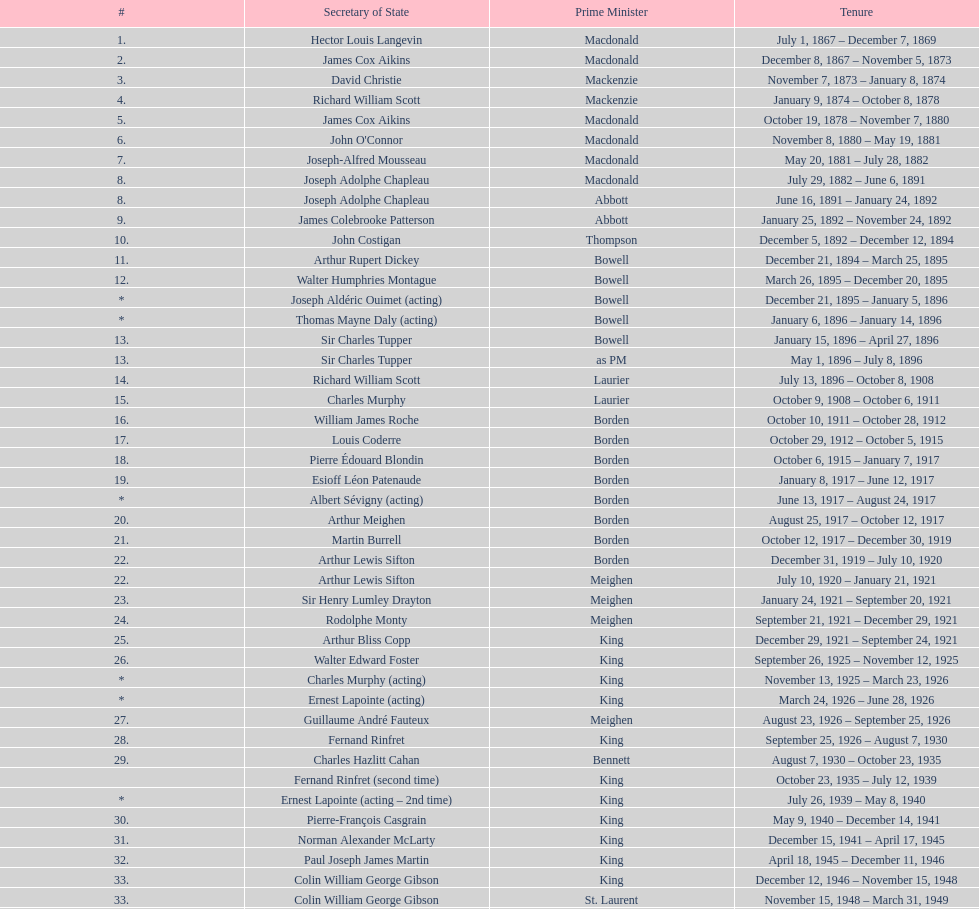How many secretaries of state were there during prime minister macdonald's tenure? 6. 